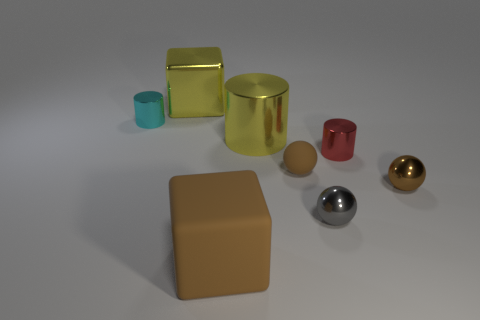Add 1 cyan metal objects. How many objects exist? 9 Subtract all balls. How many objects are left? 5 Subtract all big brown matte cubes. Subtract all cyan shiny things. How many objects are left? 6 Add 5 matte cubes. How many matte cubes are left? 6 Add 7 large brown matte objects. How many large brown matte objects exist? 8 Subtract 0 red balls. How many objects are left? 8 